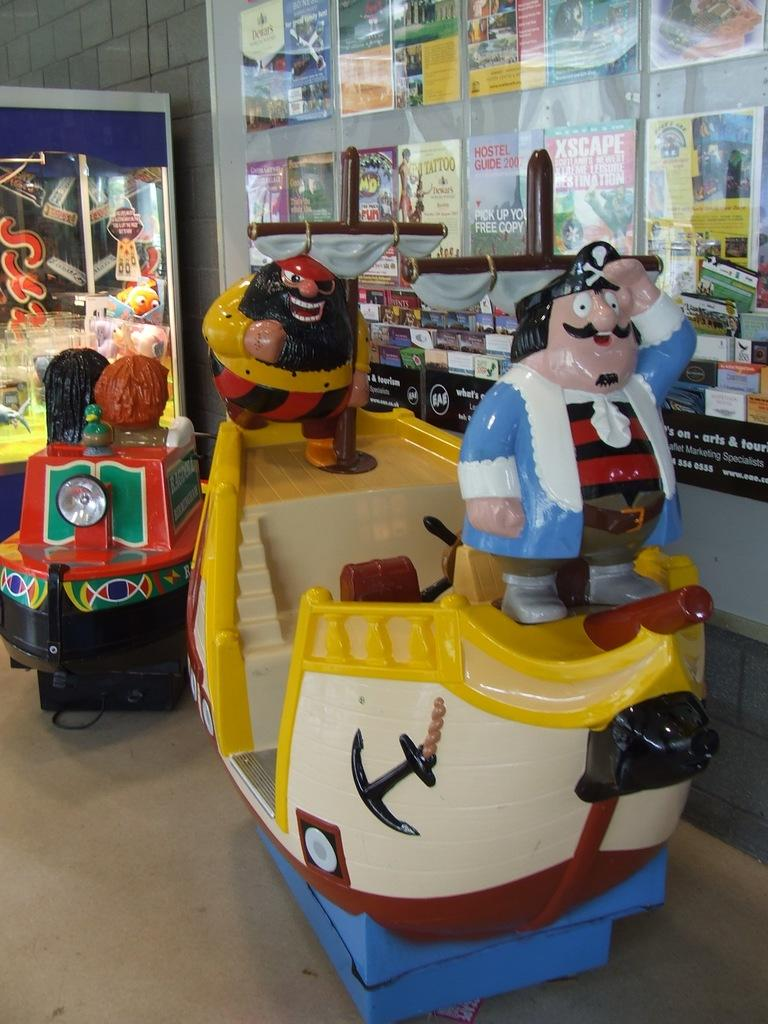<image>
Present a compact description of the photo's key features. Coin operated kids rides in front of a wall of brochures, one of which is a 2007 hostel guide. 